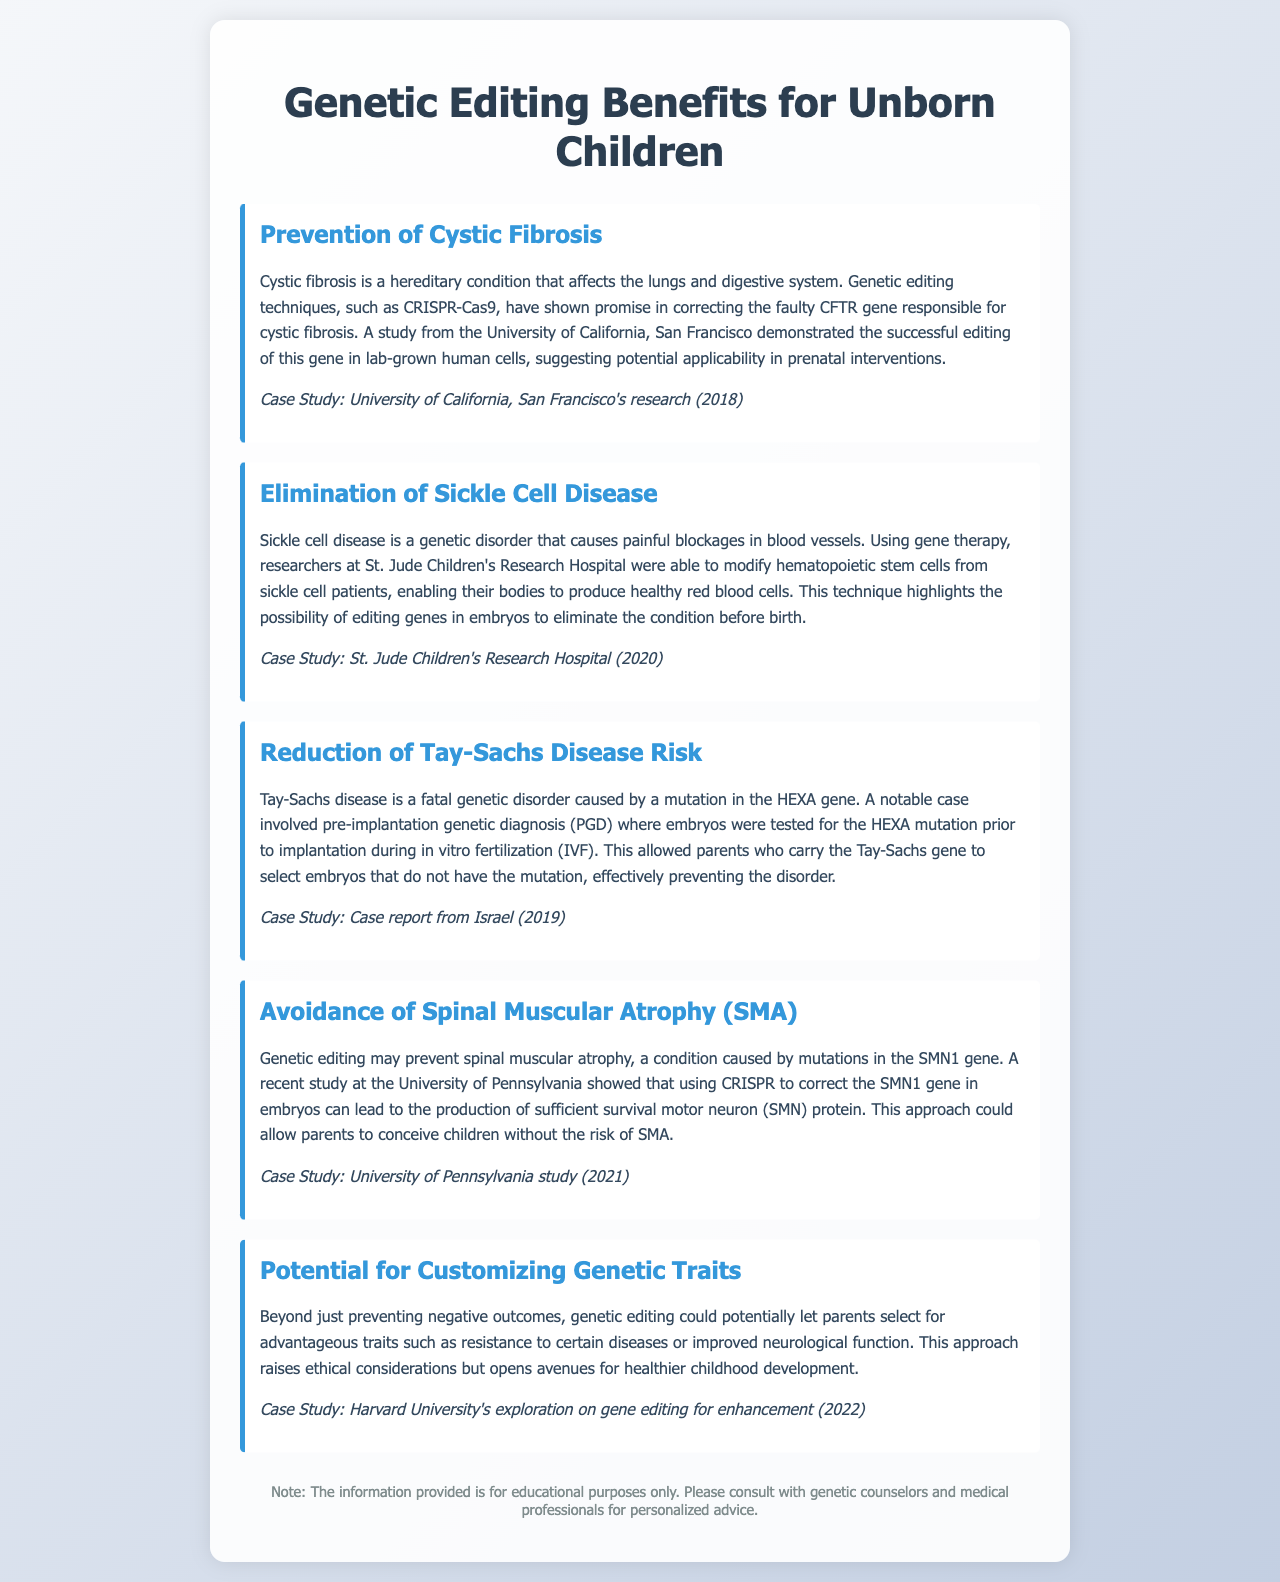What is the condition addressed in the first benefit? The first benefit discusses cystic fibrosis as the hereditary condition it addresses.
Answer: cystic fibrosis What genetic editing technique is mentioned for cystic fibrosis? The document cites CRISPR-Cas9 as the technique used for cystic fibrosis.
Answer: CRISPR-Cas9 Which hospital conducted research on sickle cell disease? The document references St. Jude Children's Research Hospital as the institution that researched sickle cell disease.
Answer: St. Jude Children's Research Hospital What year was the case study on Tay-Sachs disease reported? The document states that the case report on Tay-Sachs disease was from the year 2019.
Answer: 2019 Which gene mutation is involved in spinal muscular atrophy? The document specifies that mutations in the SMN1 gene are involved in spinal muscular atrophy.
Answer: SMN1 What potential customization does genetic editing allow according to the last benefit? The document mentions the potential for customizing advantageous traits through genetic editing.
Answer: advantageous traits Which university explored gene editing for enhancement? Harvard University is noted for exploring gene editing for enhancement.
Answer: Harvard University What is the purpose of the disclaimer at the end of the document? The disclaimer indicates that the information is for educational purposes and encourages consulting professionals.
Answer: educational purposes 